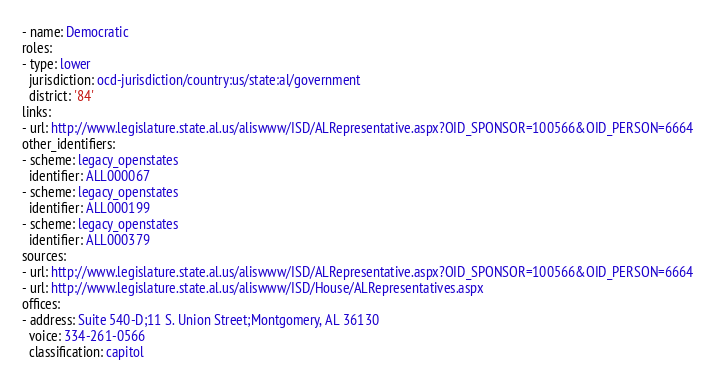<code> <loc_0><loc_0><loc_500><loc_500><_YAML_>- name: Democratic
roles:
- type: lower
  jurisdiction: ocd-jurisdiction/country:us/state:al/government
  district: '84'
links:
- url: http://www.legislature.state.al.us/aliswww/ISD/ALRepresentative.aspx?OID_SPONSOR=100566&OID_PERSON=6664
other_identifiers:
- scheme: legacy_openstates
  identifier: ALL000067
- scheme: legacy_openstates
  identifier: ALL000199
- scheme: legacy_openstates
  identifier: ALL000379
sources:
- url: http://www.legislature.state.al.us/aliswww/ISD/ALRepresentative.aspx?OID_SPONSOR=100566&OID_PERSON=6664
- url: http://www.legislature.state.al.us/aliswww/ISD/House/ALRepresentatives.aspx
offices:
- address: Suite 540-D;11 S. Union Street;Montgomery, AL 36130
  voice: 334-261-0566
  classification: capitol
</code> 